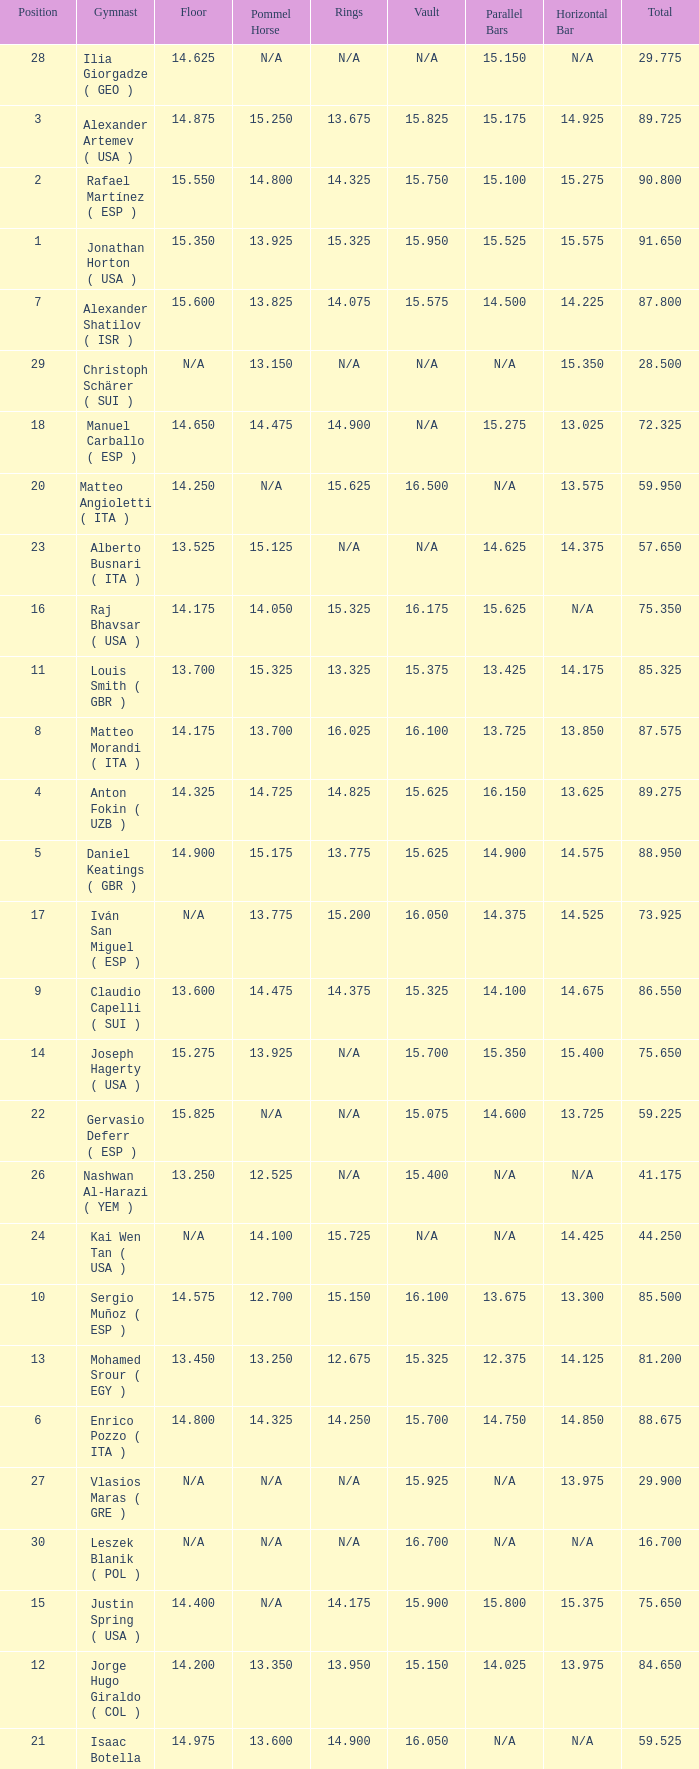If the floor number is 14.200, what is the number for the parallel bars? 14.025. 